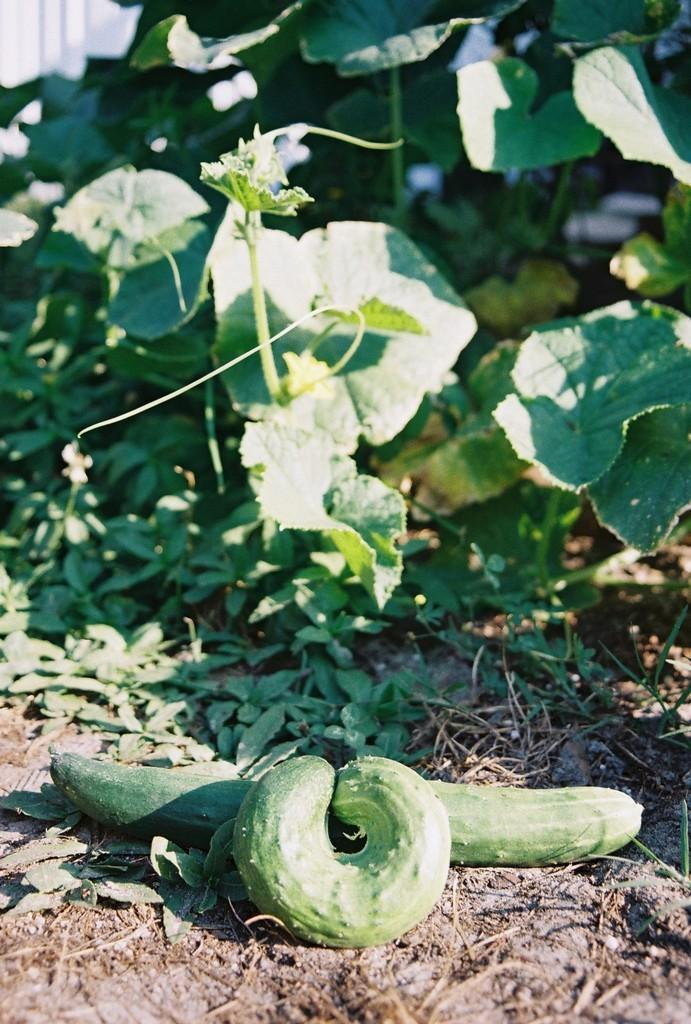What type of food items can be seen in the image? There are vegetables in the image. Where are the vegetables located in the image? The vegetables are at the bottom of the image. What other living organisms are present in the image? There are plants in the image. Where are the plants located in the image? The plants are at the top of the image. What color are the vegetables and plants in the image? The vegetables and plants are in green color. What type of knee support is visible in the image? There is no knee support present in the image. What scientific theory can be observed in the image? There is no scientific theory depicted in the image; it features vegetables and plants. 